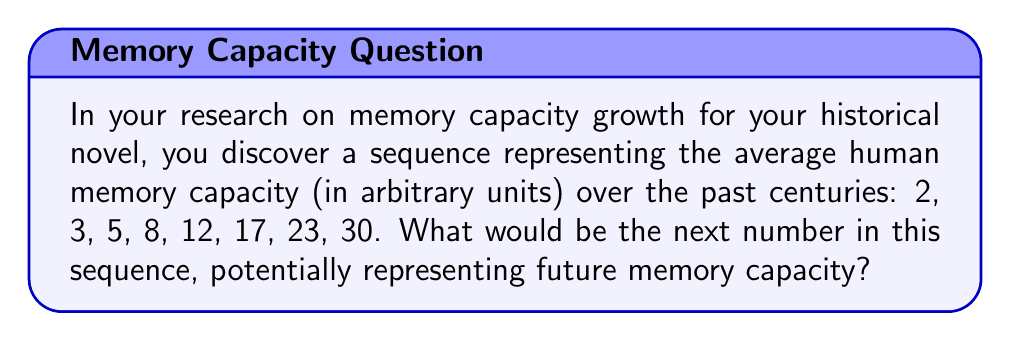Solve this math problem. To solve this problem, let's analyze the pattern in the given sequence:

2, 3, 5, 8, 12, 17, 23, 30

Step 1: Calculate the differences between consecutive terms:
$$
\begin{align*}
3 - 2 &= 1 \\
5 - 3 &= 2 \\
8 - 5 &= 3 \\
12 - 8 &= 4 \\
17 - 12 &= 5 \\
23 - 17 &= 6 \\
30 - 23 &= 7
\end{align*}
$$

Step 2: Observe that the differences form an arithmetic sequence: 1, 2, 3, 4, 5, 6, 7

Step 3: Predict the next difference in this arithmetic sequence:
The next term would be 8.

Step 4: Add this difference to the last term of the original sequence:
$30 + 8 = 38$

Therefore, the next number in the sequence, representing the potential future memory capacity, would be 38.
Answer: 38 